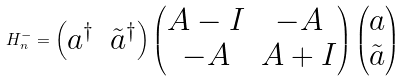Convert formula to latex. <formula><loc_0><loc_0><loc_500><loc_500>H _ { n } ^ { - } = \begin{pmatrix} a ^ { \dagger } & \tilde { a } ^ { \dagger } \end{pmatrix} \begin{pmatrix} A - I & - A \\ - A & A + I \end{pmatrix} \begin{pmatrix} a \\ \tilde { a } \end{pmatrix}</formula> 